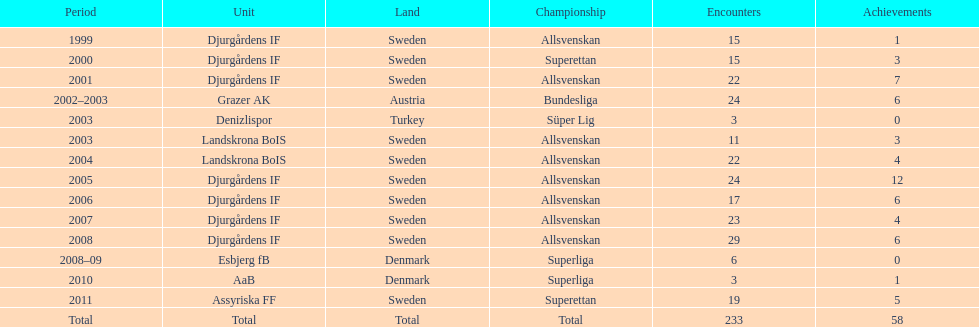What is the total number of matches? 233. Help me parse the entirety of this table. {'header': ['Period', 'Unit', 'Land', 'Championship', 'Encounters', 'Achievements'], 'rows': [['1999', 'Djurgårdens IF', 'Sweden', 'Allsvenskan', '15', '1'], ['2000', 'Djurgårdens IF', 'Sweden', 'Superettan', '15', '3'], ['2001', 'Djurgårdens IF', 'Sweden', 'Allsvenskan', '22', '7'], ['2002–2003', 'Grazer AK', 'Austria', 'Bundesliga', '24', '6'], ['2003', 'Denizlispor', 'Turkey', 'Süper Lig', '3', '0'], ['2003', 'Landskrona BoIS', 'Sweden', 'Allsvenskan', '11', '3'], ['2004', 'Landskrona BoIS', 'Sweden', 'Allsvenskan', '22', '4'], ['2005', 'Djurgårdens IF', 'Sweden', 'Allsvenskan', '24', '12'], ['2006', 'Djurgårdens IF', 'Sweden', 'Allsvenskan', '17', '6'], ['2007', 'Djurgårdens IF', 'Sweden', 'Allsvenskan', '23', '4'], ['2008', 'Djurgårdens IF', 'Sweden', 'Allsvenskan', '29', '6'], ['2008–09', 'Esbjerg fB', 'Denmark', 'Superliga', '6', '0'], ['2010', 'AaB', 'Denmark', 'Superliga', '3', '1'], ['2011', 'Assyriska FF', 'Sweden', 'Superettan', '19', '5'], ['Total', 'Total', 'Total', 'Total', '233', '58']]} 